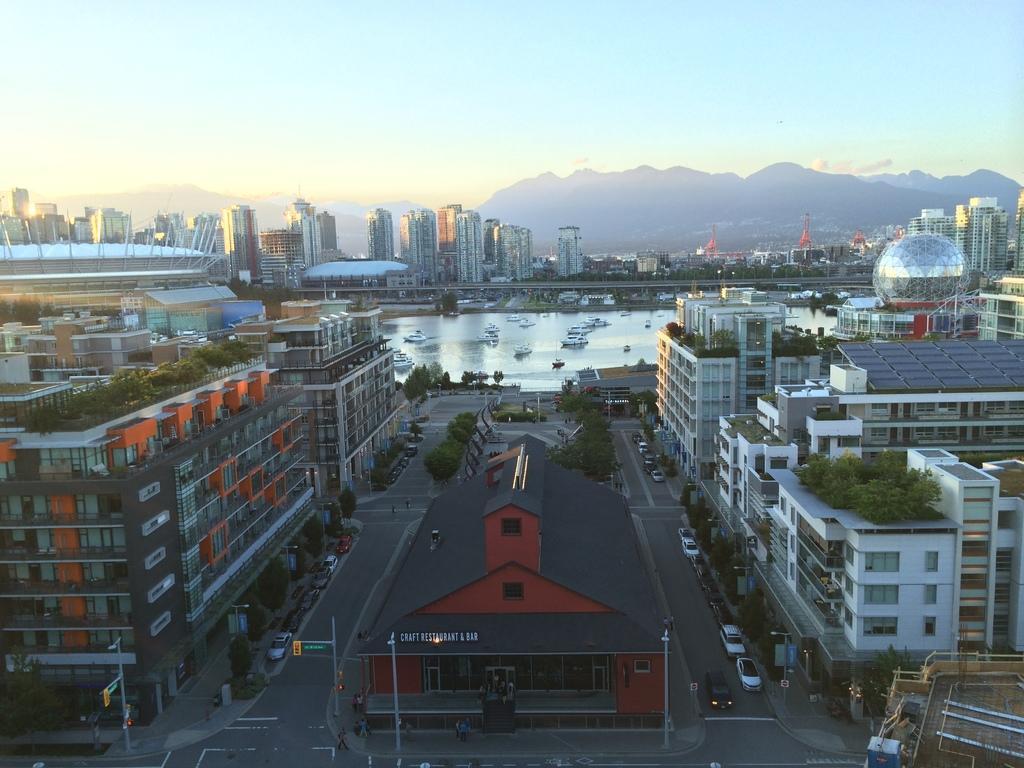Can you describe this image briefly? In this picture we can see the Aerial view of a city with many vehicles on the road, & many buildings. Here the sky is bright. 